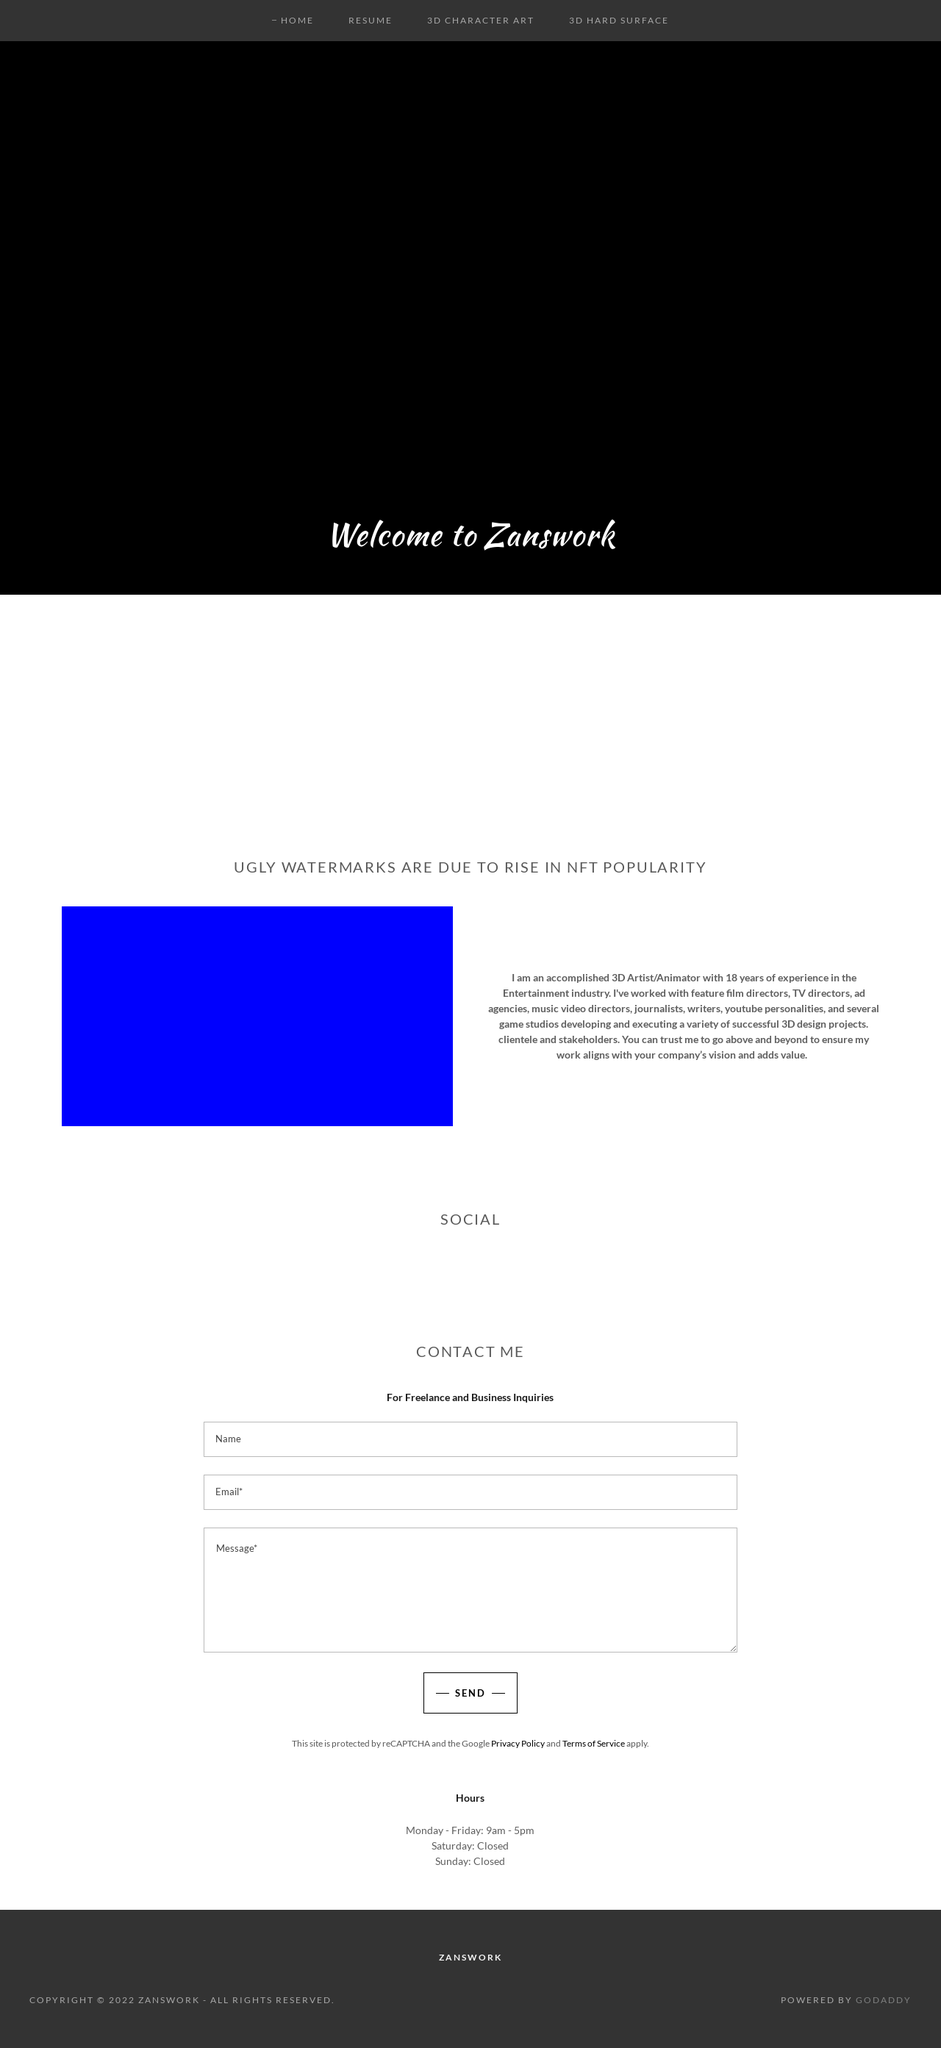How can I start building this website with HTML from the ground up? To start building a website from the ground up using HTML, initiate by setting up the basic structure of your website using the provided HTML skeleton. This skeleton includes essential meta tags for defining character set, viewport settings, SEO optimizations, and basic social media integration through Open Graph and Twitter cards properties. After establishing this foundation, you can expand your site by adding CSS for styling and JavaScript for interactive elements. Moreover, incorporate elements such as navigation menus, image galleries, and contact forms to enhance user engagement. Always ensure to test your website across different devices and browsers for responsiveness and compatibility. 